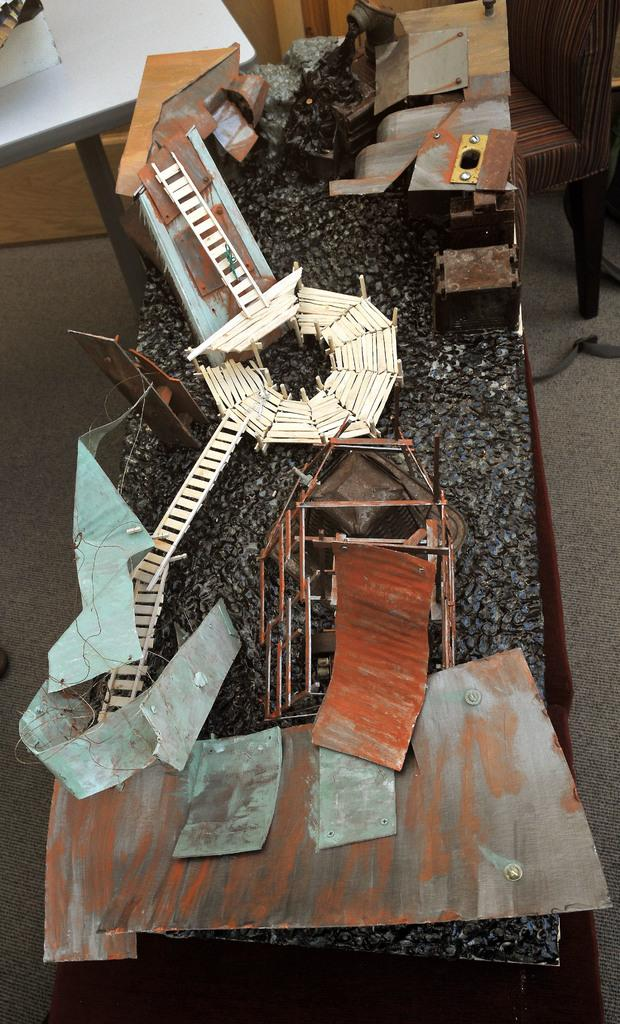What objects can be seen in the image? There are sticks, metal sheets, a ladder, a chair, and a table visible in the image. How is the ladder positioned in the image? The ladder is placed on a table in the image. What is present on the ground in the background of the image? There is a rope placed on the ground in the background of the image. What type of books are stacked on the ladder in the image? There are no books present in the image; it features sticks, metal sheets, a ladder, a chair, and a table. What is the army doing in the image? There is no army or any military-related activity depicted in the image. 